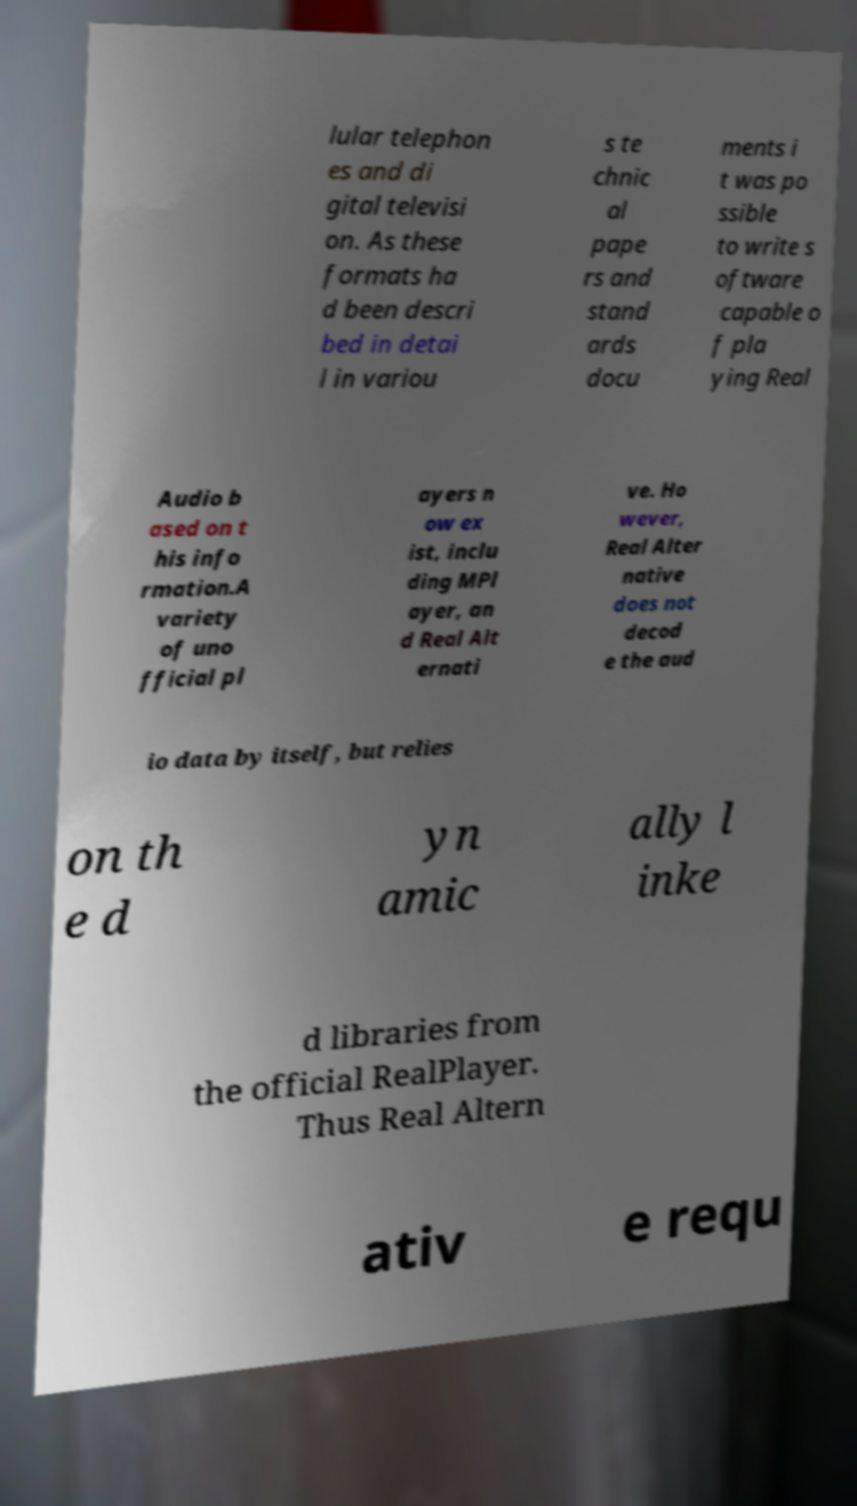Could you assist in decoding the text presented in this image and type it out clearly? lular telephon es and di gital televisi on. As these formats ha d been descri bed in detai l in variou s te chnic al pape rs and stand ards docu ments i t was po ssible to write s oftware capable o f pla ying Real Audio b ased on t his info rmation.A variety of uno fficial pl ayers n ow ex ist, inclu ding MPl ayer, an d Real Alt ernati ve. Ho wever, Real Alter native does not decod e the aud io data by itself, but relies on th e d yn amic ally l inke d libraries from the official RealPlayer. Thus Real Altern ativ e requ 